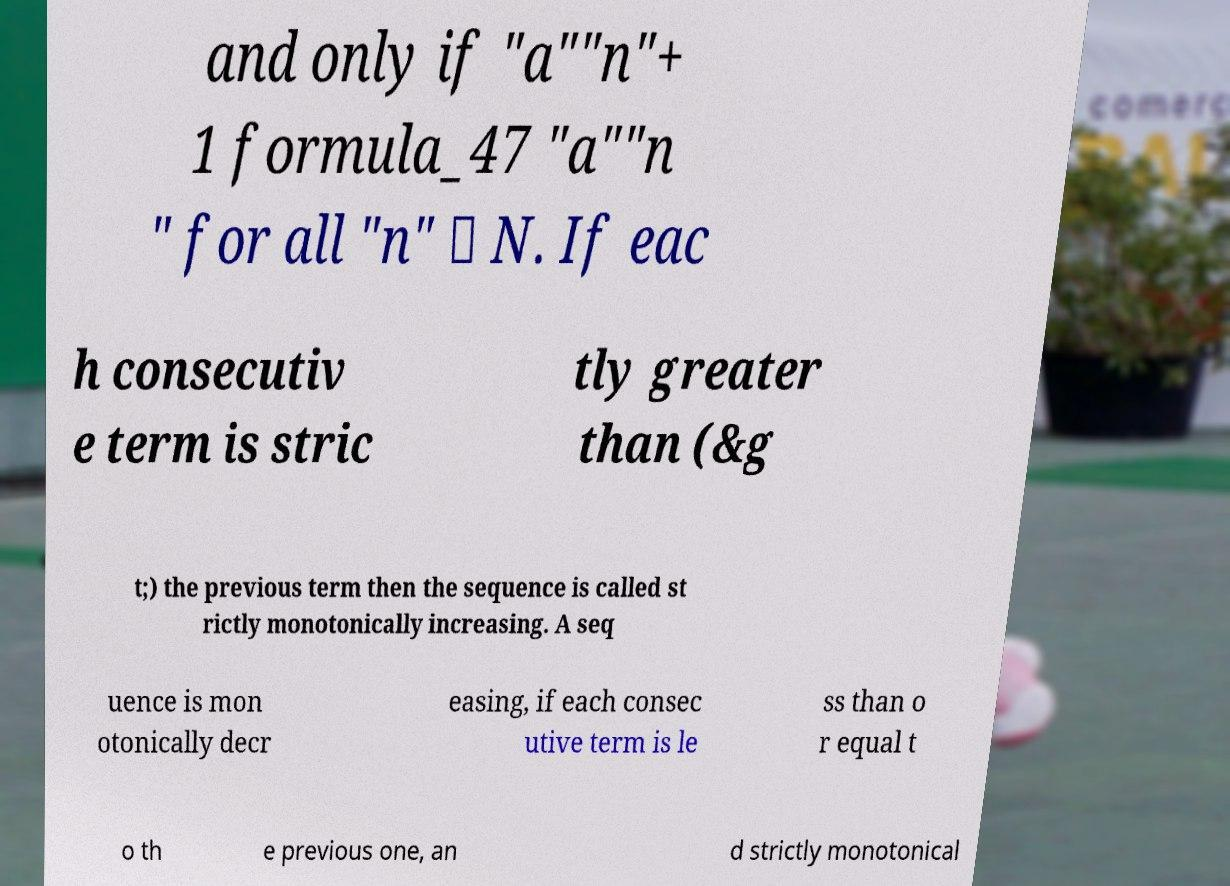I need the written content from this picture converted into text. Can you do that? and only if "a""n"+ 1 formula_47 "a""n " for all "n" ∈ N. If eac h consecutiv e term is stric tly greater than (&g t;) the previous term then the sequence is called st rictly monotonically increasing. A seq uence is mon otonically decr easing, if each consec utive term is le ss than o r equal t o th e previous one, an d strictly monotonical 